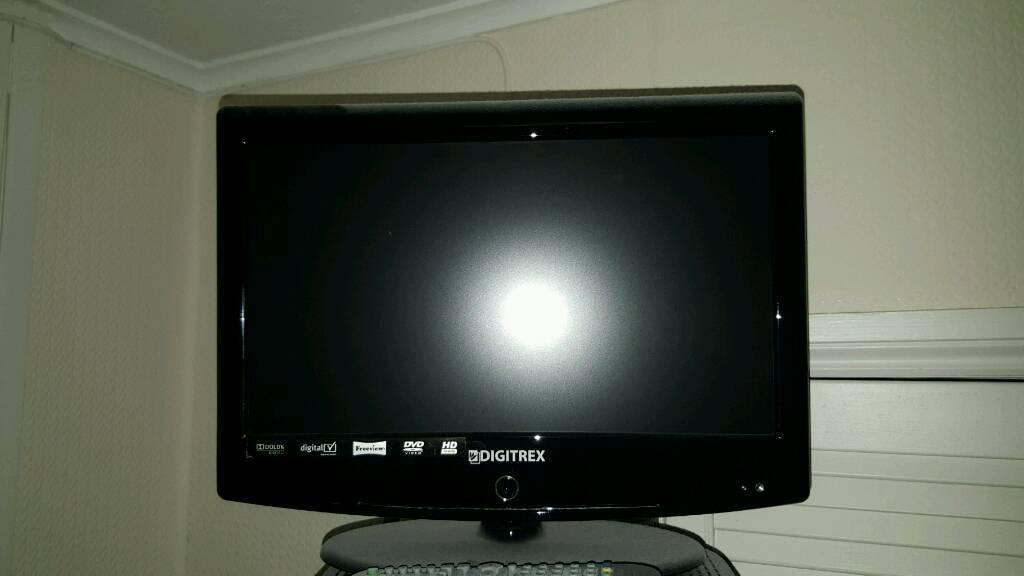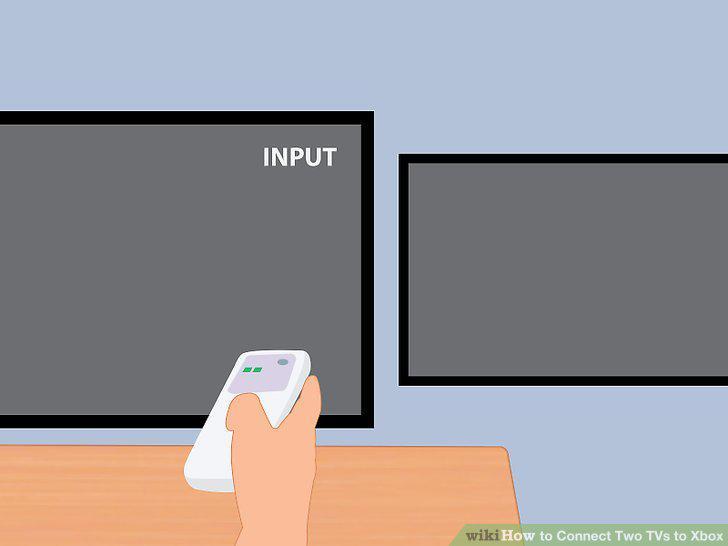The first image is the image on the left, the second image is the image on the right. Given the left and right images, does the statement "Two televisions touch each other in at least one of the images." hold true? Answer yes or no. No. The first image is the image on the left, the second image is the image on the right. Examine the images to the left and right. Is the description "An image shows a smaller dark-screened TV with a bigger dark-screened TV, and both are sitting on some type of surface." accurate? Answer yes or no. No. 